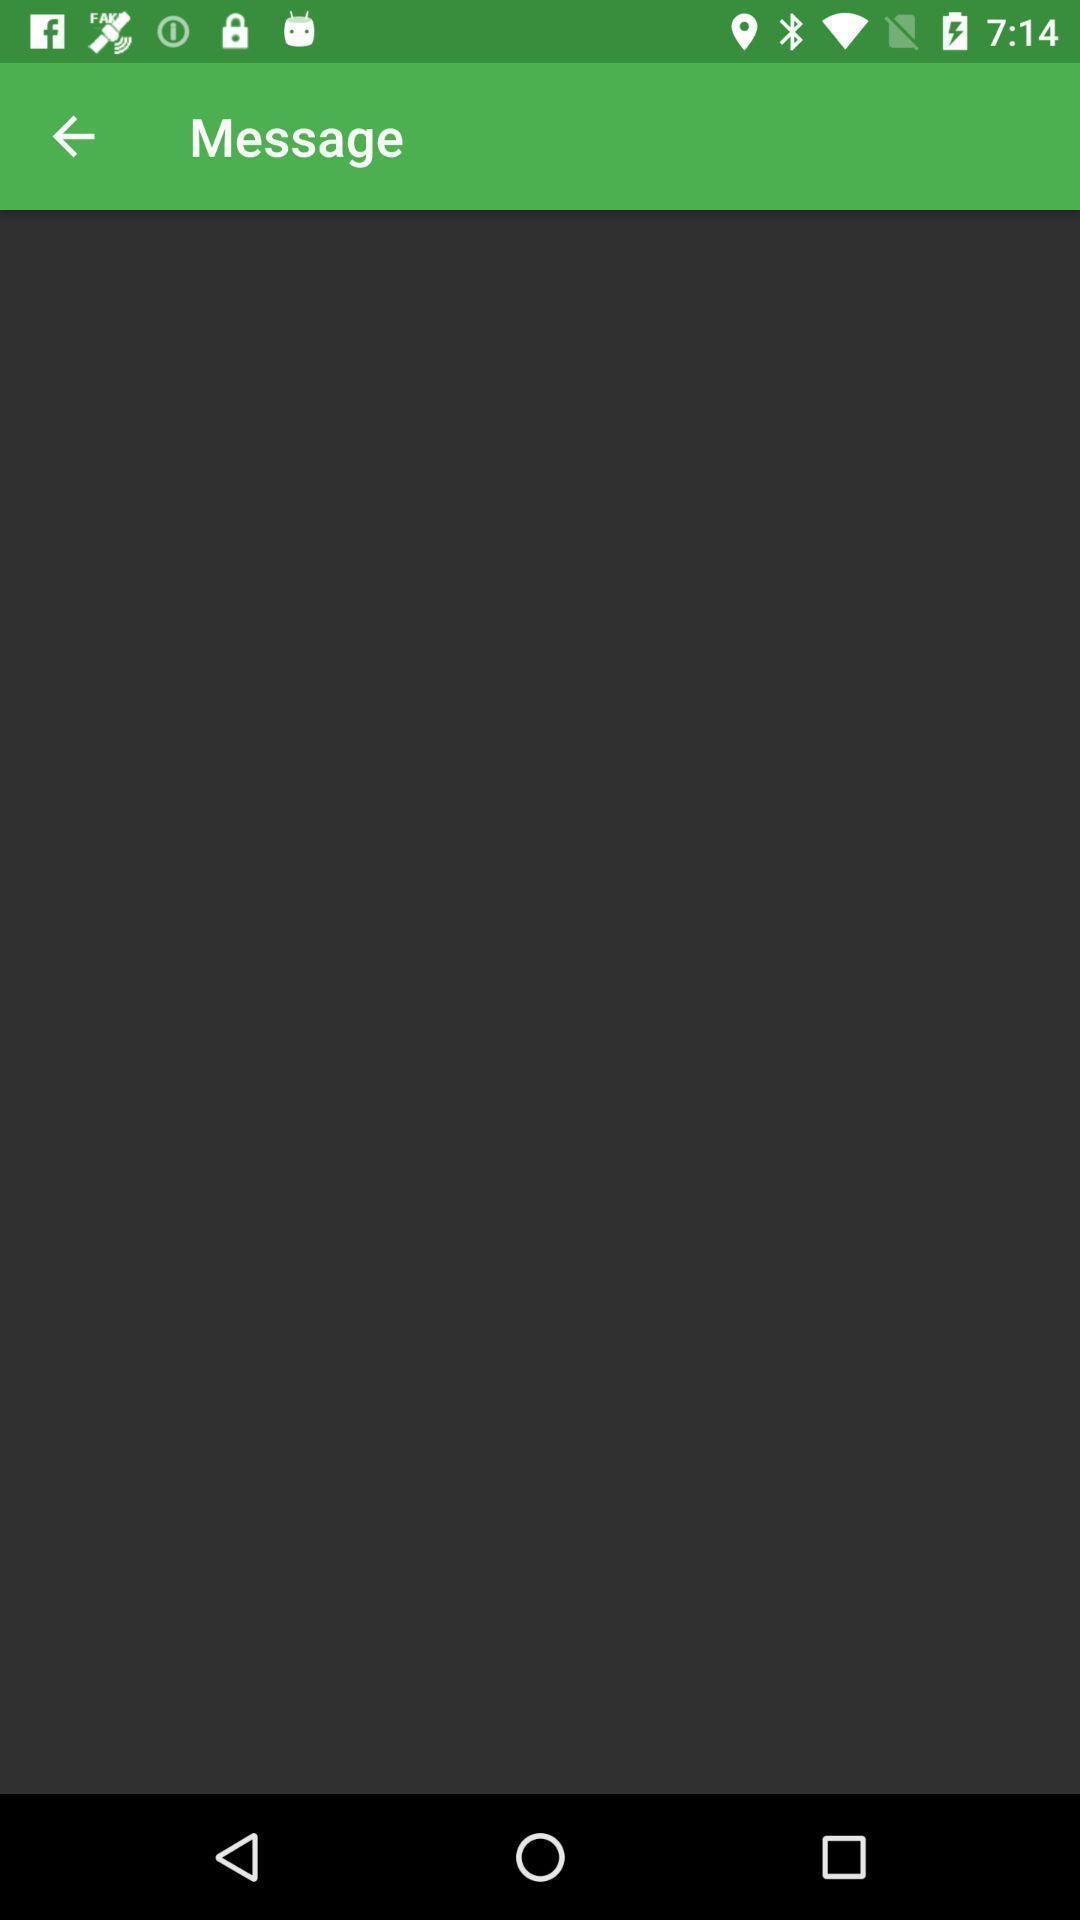Give me a summary of this screen capture. Screen displaying the blank page. 